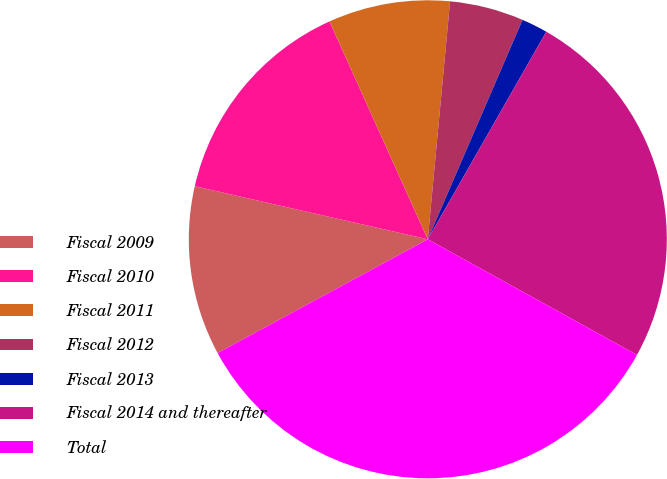Convert chart to OTSL. <chart><loc_0><loc_0><loc_500><loc_500><pie_chart><fcel>Fiscal 2009<fcel>Fiscal 2010<fcel>Fiscal 2011<fcel>Fiscal 2012<fcel>Fiscal 2013<fcel>Fiscal 2014 and thereafter<fcel>Total<nl><fcel>11.46%<fcel>14.69%<fcel>8.23%<fcel>5.0%<fcel>1.77%<fcel>24.78%<fcel>34.07%<nl></chart> 